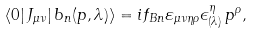Convert formula to latex. <formula><loc_0><loc_0><loc_500><loc_500>\langle 0 | \, J _ { \mu \nu } | \, b _ { n } ( p , \lambda ) \rangle = i f _ { B n } \varepsilon _ { \mu \nu \eta \rho } \epsilon ^ { \eta } _ { ( \lambda ) } \, p ^ { \rho } ,</formula> 